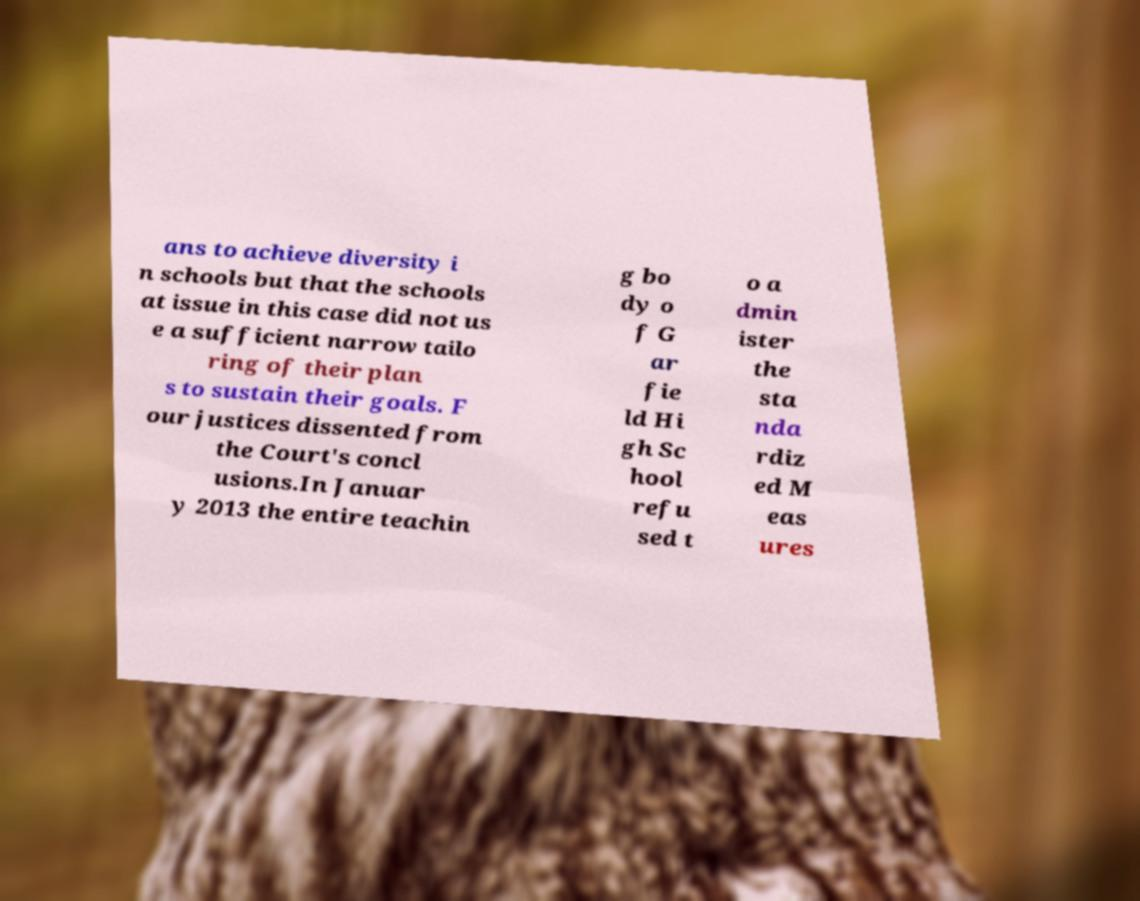Please read and relay the text visible in this image. What does it say? ans to achieve diversity i n schools but that the schools at issue in this case did not us e a sufficient narrow tailo ring of their plan s to sustain their goals. F our justices dissented from the Court's concl usions.In Januar y 2013 the entire teachin g bo dy o f G ar fie ld Hi gh Sc hool refu sed t o a dmin ister the sta nda rdiz ed M eas ures 